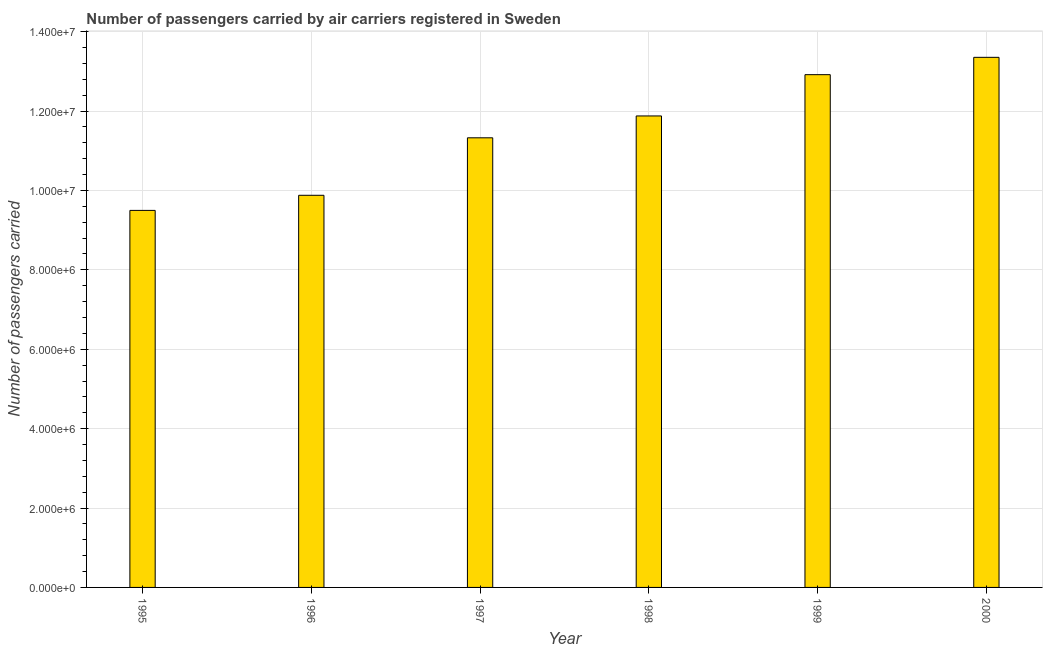What is the title of the graph?
Ensure brevity in your answer.  Number of passengers carried by air carriers registered in Sweden. What is the label or title of the Y-axis?
Your answer should be very brief. Number of passengers carried. What is the number of passengers carried in 2000?
Offer a terse response. 1.34e+07. Across all years, what is the maximum number of passengers carried?
Ensure brevity in your answer.  1.34e+07. Across all years, what is the minimum number of passengers carried?
Provide a succinct answer. 9.50e+06. In which year was the number of passengers carried maximum?
Your answer should be very brief. 2000. In which year was the number of passengers carried minimum?
Offer a terse response. 1995. What is the sum of the number of passengers carried?
Offer a very short reply. 6.89e+07. What is the difference between the number of passengers carried in 1996 and 1997?
Your answer should be compact. -1.45e+06. What is the average number of passengers carried per year?
Give a very brief answer. 1.15e+07. What is the median number of passengers carried?
Make the answer very short. 1.16e+07. In how many years, is the number of passengers carried greater than 12000000 ?
Make the answer very short. 2. Do a majority of the years between 1999 and 1996 (inclusive) have number of passengers carried greater than 12800000 ?
Your answer should be compact. Yes. What is the ratio of the number of passengers carried in 1996 to that in 1999?
Keep it short and to the point. 0.77. Is the difference between the number of passengers carried in 1997 and 2000 greater than the difference between any two years?
Make the answer very short. No. What is the difference between the highest and the second highest number of passengers carried?
Provide a short and direct response. 4.37e+05. Is the sum of the number of passengers carried in 1997 and 1999 greater than the maximum number of passengers carried across all years?
Ensure brevity in your answer.  Yes. What is the difference between the highest and the lowest number of passengers carried?
Provide a short and direct response. 3.86e+06. How many years are there in the graph?
Make the answer very short. 6. What is the difference between two consecutive major ticks on the Y-axis?
Ensure brevity in your answer.  2.00e+06. What is the Number of passengers carried of 1995?
Ensure brevity in your answer.  9.50e+06. What is the Number of passengers carried in 1996?
Offer a terse response. 9.88e+06. What is the Number of passengers carried in 1997?
Your answer should be very brief. 1.13e+07. What is the Number of passengers carried in 1998?
Provide a short and direct response. 1.19e+07. What is the Number of passengers carried of 1999?
Ensure brevity in your answer.  1.29e+07. What is the Number of passengers carried of 2000?
Provide a short and direct response. 1.34e+07. What is the difference between the Number of passengers carried in 1995 and 1996?
Your response must be concise. -3.81e+05. What is the difference between the Number of passengers carried in 1995 and 1997?
Your response must be concise. -1.83e+06. What is the difference between the Number of passengers carried in 1995 and 1998?
Offer a terse response. -2.38e+06. What is the difference between the Number of passengers carried in 1995 and 1999?
Offer a very short reply. -3.42e+06. What is the difference between the Number of passengers carried in 1995 and 2000?
Offer a very short reply. -3.86e+06. What is the difference between the Number of passengers carried in 1996 and 1997?
Your answer should be very brief. -1.45e+06. What is the difference between the Number of passengers carried in 1996 and 1998?
Keep it short and to the point. -2.00e+06. What is the difference between the Number of passengers carried in 1996 and 1999?
Your response must be concise. -3.04e+06. What is the difference between the Number of passengers carried in 1996 and 2000?
Offer a very short reply. -3.48e+06. What is the difference between the Number of passengers carried in 1997 and 1998?
Offer a terse response. -5.51e+05. What is the difference between the Number of passengers carried in 1997 and 1999?
Offer a very short reply. -1.59e+06. What is the difference between the Number of passengers carried in 1997 and 2000?
Ensure brevity in your answer.  -2.03e+06. What is the difference between the Number of passengers carried in 1998 and 1999?
Your answer should be compact. -1.04e+06. What is the difference between the Number of passengers carried in 1998 and 2000?
Your answer should be very brief. -1.48e+06. What is the difference between the Number of passengers carried in 1999 and 2000?
Offer a terse response. -4.37e+05. What is the ratio of the Number of passengers carried in 1995 to that in 1996?
Offer a terse response. 0.96. What is the ratio of the Number of passengers carried in 1995 to that in 1997?
Offer a terse response. 0.84. What is the ratio of the Number of passengers carried in 1995 to that in 1998?
Provide a succinct answer. 0.8. What is the ratio of the Number of passengers carried in 1995 to that in 1999?
Your answer should be compact. 0.73. What is the ratio of the Number of passengers carried in 1995 to that in 2000?
Keep it short and to the point. 0.71. What is the ratio of the Number of passengers carried in 1996 to that in 1997?
Your response must be concise. 0.87. What is the ratio of the Number of passengers carried in 1996 to that in 1998?
Make the answer very short. 0.83. What is the ratio of the Number of passengers carried in 1996 to that in 1999?
Your answer should be compact. 0.77. What is the ratio of the Number of passengers carried in 1996 to that in 2000?
Provide a succinct answer. 0.74. What is the ratio of the Number of passengers carried in 1997 to that in 1998?
Keep it short and to the point. 0.95. What is the ratio of the Number of passengers carried in 1997 to that in 1999?
Your response must be concise. 0.88. What is the ratio of the Number of passengers carried in 1997 to that in 2000?
Give a very brief answer. 0.85. What is the ratio of the Number of passengers carried in 1998 to that in 1999?
Make the answer very short. 0.92. What is the ratio of the Number of passengers carried in 1998 to that in 2000?
Ensure brevity in your answer.  0.89. 